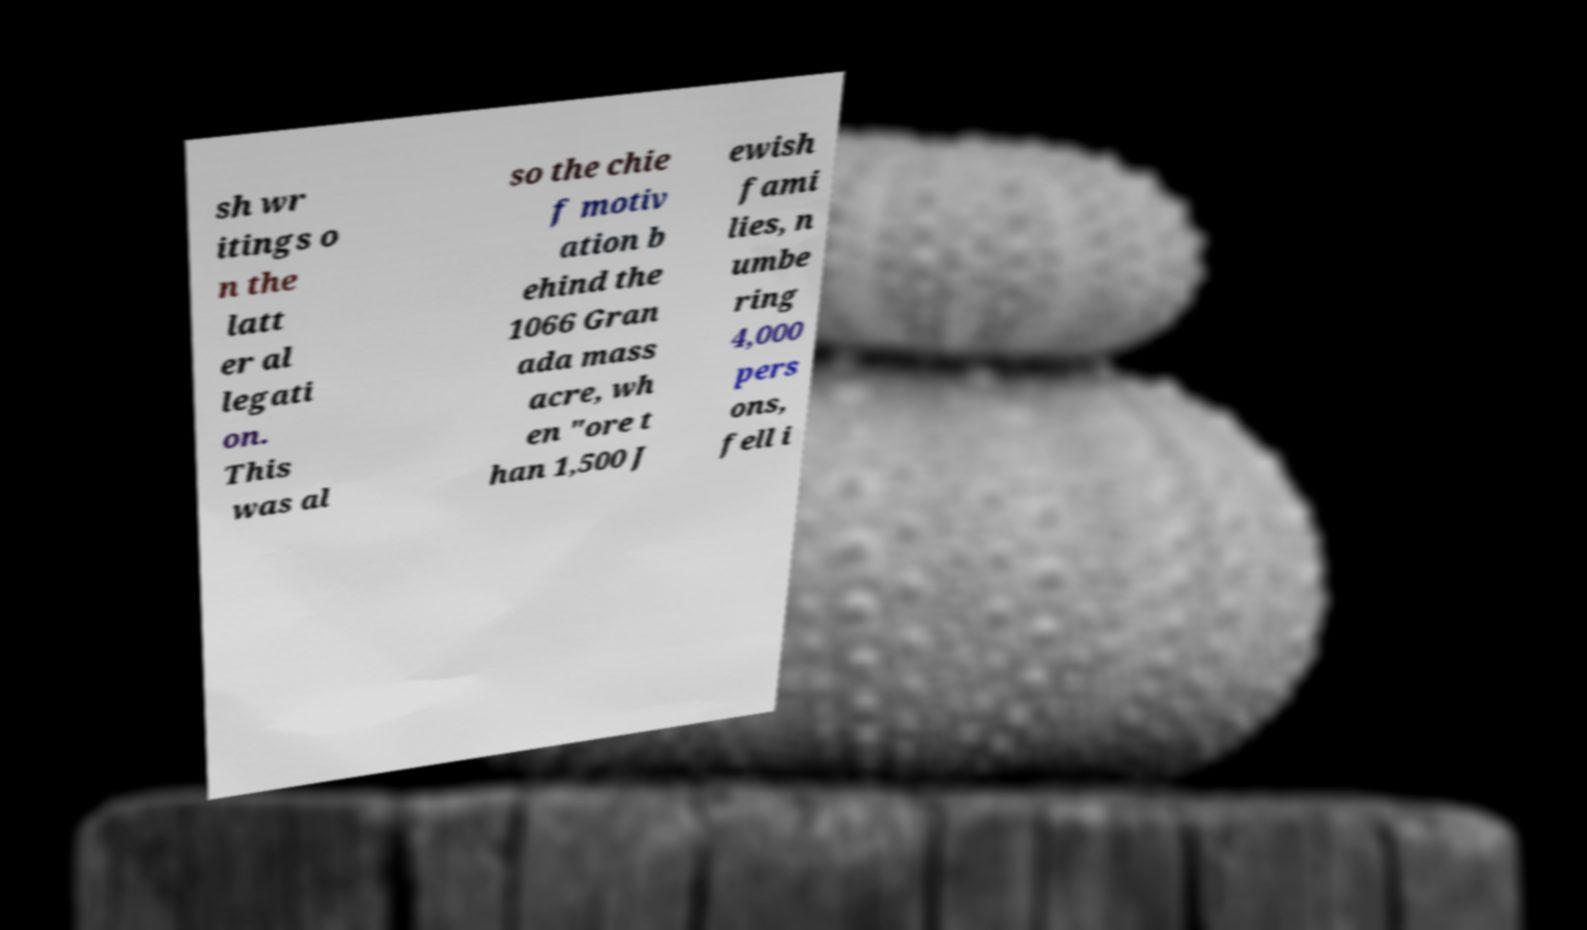Please identify and transcribe the text found in this image. sh wr itings o n the latt er al legati on. This was al so the chie f motiv ation b ehind the 1066 Gran ada mass acre, wh en "ore t han 1,500 J ewish fami lies, n umbe ring 4,000 pers ons, fell i 